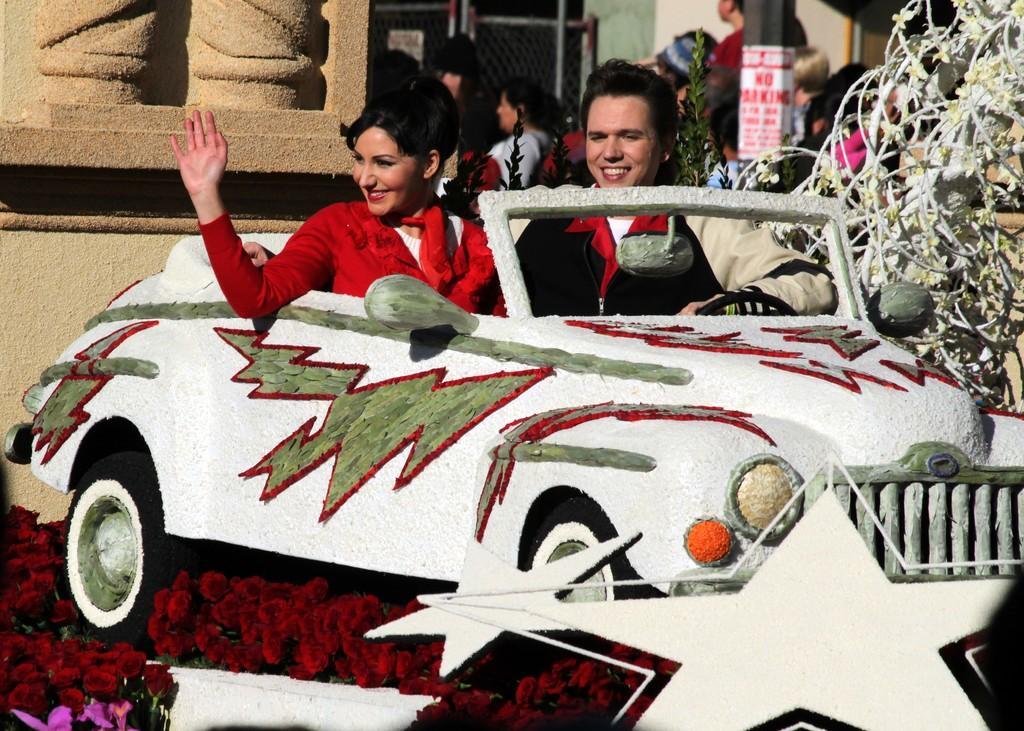Describe this image in one or two sentences. In this image I can see a man and a woman are sitting in a vehicle. In the background I can see few more people. Here I can see smile on few faces. 